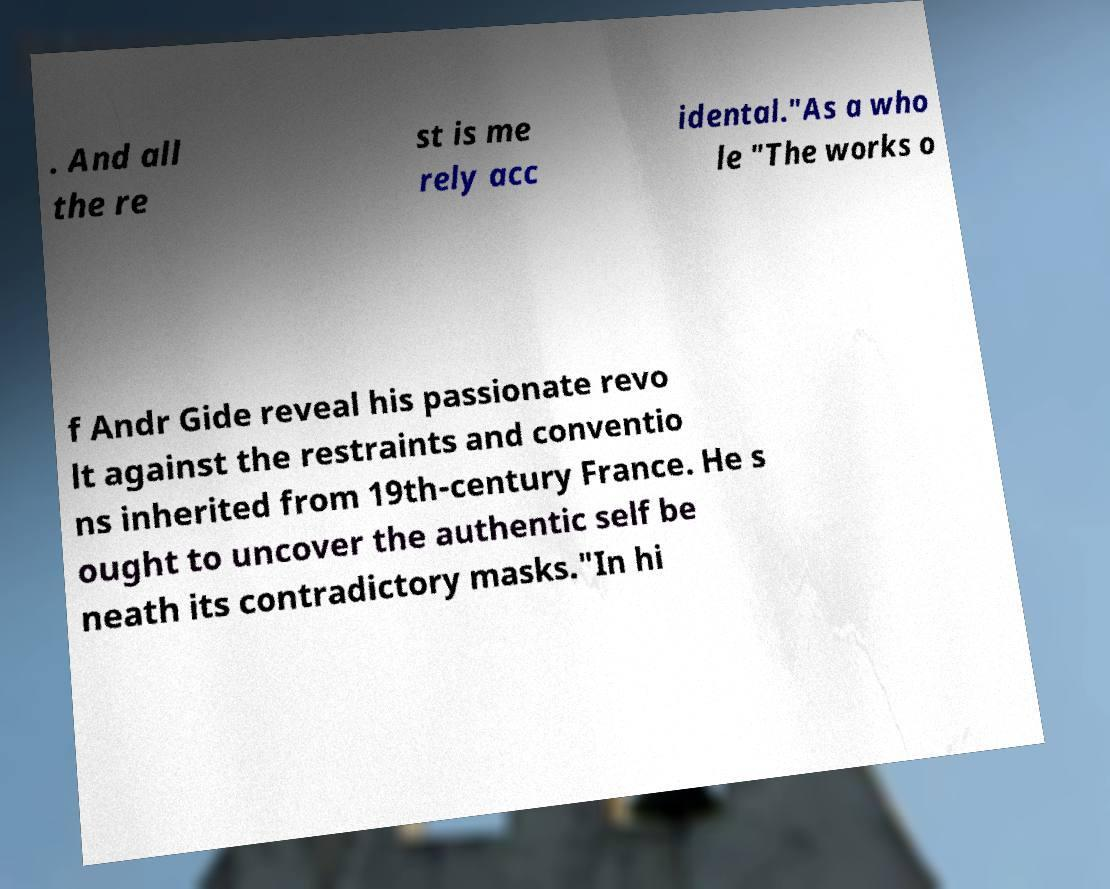I need the written content from this picture converted into text. Can you do that? . And all the re st is me rely acc idental."As a who le "The works o f Andr Gide reveal his passionate revo lt against the restraints and conventio ns inherited from 19th-century France. He s ought to uncover the authentic self be neath its contradictory masks."In hi 